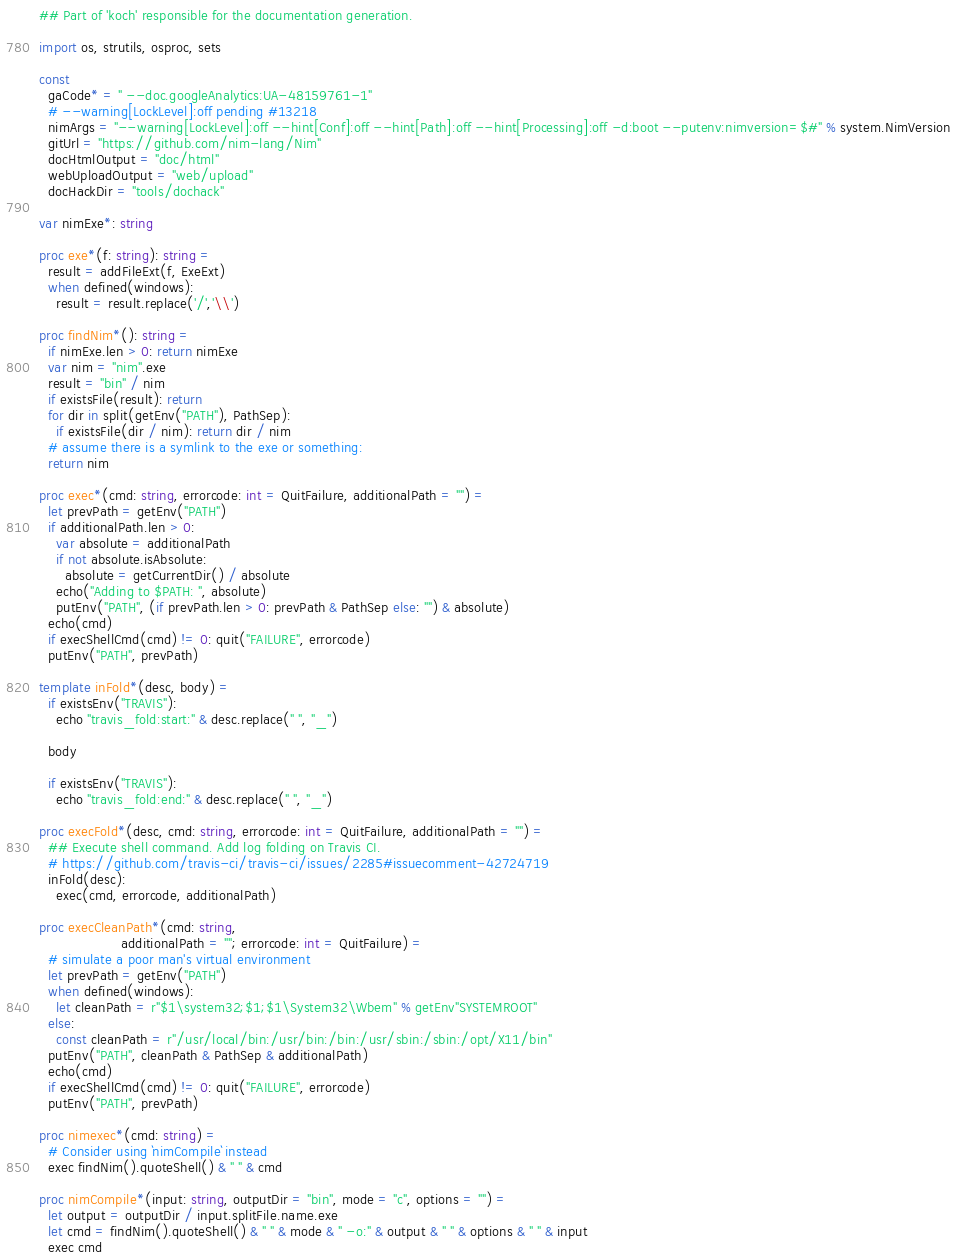Convert code to text. <code><loc_0><loc_0><loc_500><loc_500><_Nim_>## Part of 'koch' responsible for the documentation generation.

import os, strutils, osproc, sets

const
  gaCode* = " --doc.googleAnalytics:UA-48159761-1"
  # --warning[LockLevel]:off pending #13218
  nimArgs = "--warning[LockLevel]:off --hint[Conf]:off --hint[Path]:off --hint[Processing]:off -d:boot --putenv:nimversion=$#" % system.NimVersion
  gitUrl = "https://github.com/nim-lang/Nim"
  docHtmlOutput = "doc/html"
  webUploadOutput = "web/upload"
  docHackDir = "tools/dochack"

var nimExe*: string

proc exe*(f: string): string =
  result = addFileExt(f, ExeExt)
  when defined(windows):
    result = result.replace('/','\\')

proc findNim*(): string =
  if nimExe.len > 0: return nimExe
  var nim = "nim".exe
  result = "bin" / nim
  if existsFile(result): return
  for dir in split(getEnv("PATH"), PathSep):
    if existsFile(dir / nim): return dir / nim
  # assume there is a symlink to the exe or something:
  return nim

proc exec*(cmd: string, errorcode: int = QuitFailure, additionalPath = "") =
  let prevPath = getEnv("PATH")
  if additionalPath.len > 0:
    var absolute = additionalPath
    if not absolute.isAbsolute:
      absolute = getCurrentDir() / absolute
    echo("Adding to $PATH: ", absolute)
    putEnv("PATH", (if prevPath.len > 0: prevPath & PathSep else: "") & absolute)
  echo(cmd)
  if execShellCmd(cmd) != 0: quit("FAILURE", errorcode)
  putEnv("PATH", prevPath)

template inFold*(desc, body) =
  if existsEnv("TRAVIS"):
    echo "travis_fold:start:" & desc.replace(" ", "_")

  body

  if existsEnv("TRAVIS"):
    echo "travis_fold:end:" & desc.replace(" ", "_")

proc execFold*(desc, cmd: string, errorcode: int = QuitFailure, additionalPath = "") =
  ## Execute shell command. Add log folding on Travis CI.
  # https://github.com/travis-ci/travis-ci/issues/2285#issuecomment-42724719
  inFold(desc):
    exec(cmd, errorcode, additionalPath)

proc execCleanPath*(cmd: string,
                   additionalPath = ""; errorcode: int = QuitFailure) =
  # simulate a poor man's virtual environment
  let prevPath = getEnv("PATH")
  when defined(windows):
    let cleanPath = r"$1\system32;$1;$1\System32\Wbem" % getEnv"SYSTEMROOT"
  else:
    const cleanPath = r"/usr/local/bin:/usr/bin:/bin:/usr/sbin:/sbin:/opt/X11/bin"
  putEnv("PATH", cleanPath & PathSep & additionalPath)
  echo(cmd)
  if execShellCmd(cmd) != 0: quit("FAILURE", errorcode)
  putEnv("PATH", prevPath)

proc nimexec*(cmd: string) =
  # Consider using `nimCompile` instead
  exec findNim().quoteShell() & " " & cmd

proc nimCompile*(input: string, outputDir = "bin", mode = "c", options = "") =
  let output = outputDir / input.splitFile.name.exe
  let cmd = findNim().quoteShell() & " " & mode & " -o:" & output & " " & options & " " & input
  exec cmd
</code> 